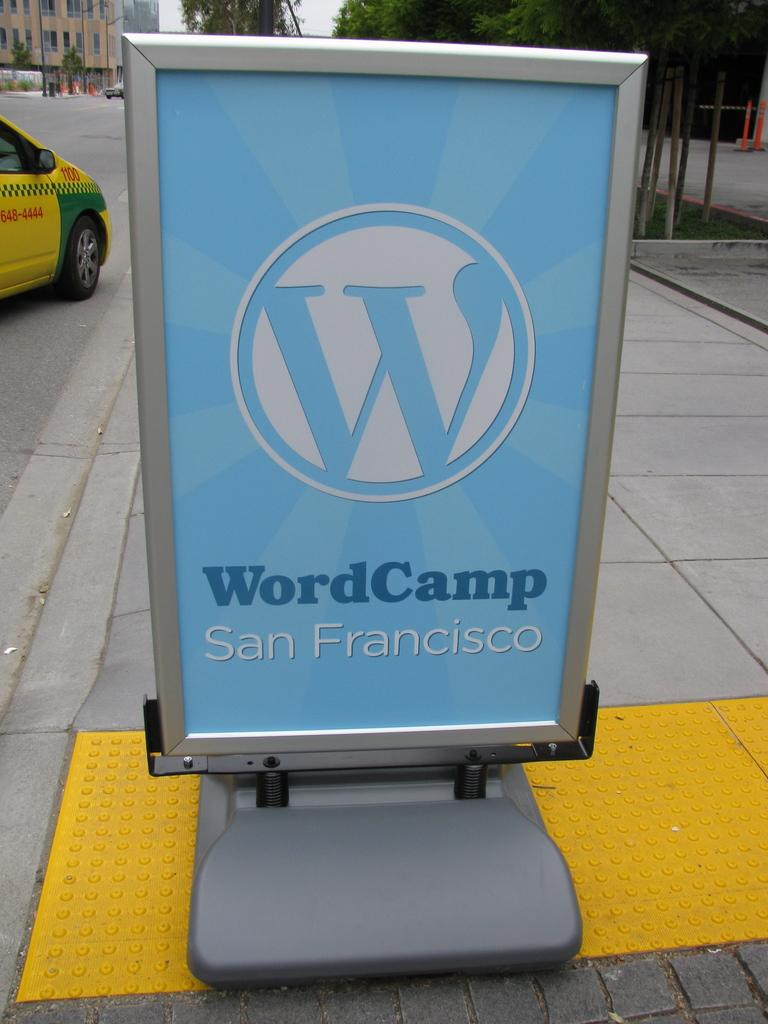Provide a one-sentence caption for the provided image. A portable sign identifies the San Francisco location of the WordCamp event. 